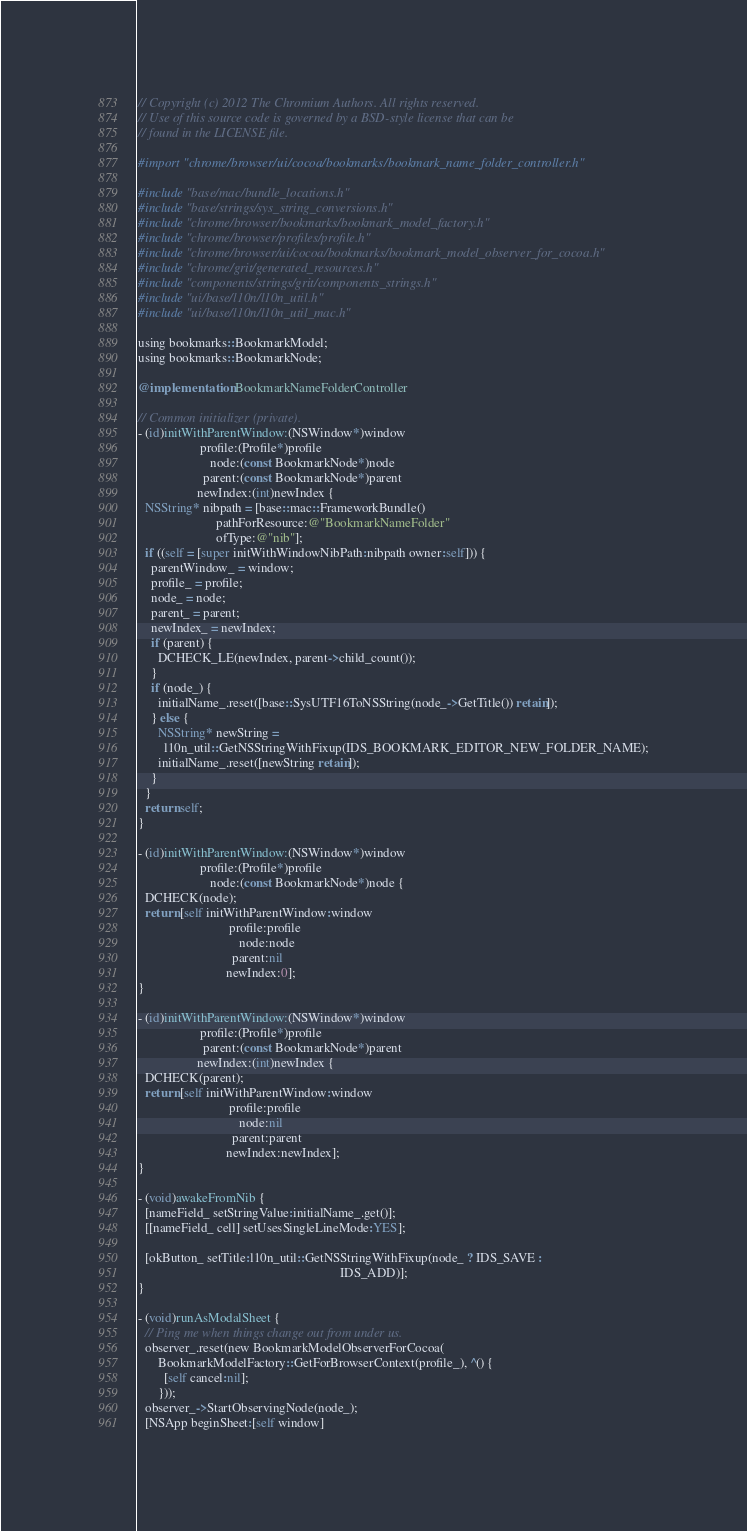Convert code to text. <code><loc_0><loc_0><loc_500><loc_500><_ObjectiveC_>// Copyright (c) 2012 The Chromium Authors. All rights reserved.
// Use of this source code is governed by a BSD-style license that can be
// found in the LICENSE file.

#import "chrome/browser/ui/cocoa/bookmarks/bookmark_name_folder_controller.h"

#include "base/mac/bundle_locations.h"
#include "base/strings/sys_string_conversions.h"
#include "chrome/browser/bookmarks/bookmark_model_factory.h"
#include "chrome/browser/profiles/profile.h"
#include "chrome/browser/ui/cocoa/bookmarks/bookmark_model_observer_for_cocoa.h"
#include "chrome/grit/generated_resources.h"
#include "components/strings/grit/components_strings.h"
#include "ui/base/l10n/l10n_util.h"
#include "ui/base/l10n/l10n_util_mac.h"

using bookmarks::BookmarkModel;
using bookmarks::BookmarkNode;

@implementation BookmarkNameFolderController

// Common initializer (private).
- (id)initWithParentWindow:(NSWindow*)window
                   profile:(Profile*)profile
                      node:(const BookmarkNode*)node
                    parent:(const BookmarkNode*)parent
                  newIndex:(int)newIndex {
  NSString* nibpath = [base::mac::FrameworkBundle()
                        pathForResource:@"BookmarkNameFolder"
                        ofType:@"nib"];
  if ((self = [super initWithWindowNibPath:nibpath owner:self])) {
    parentWindow_ = window;
    profile_ = profile;
    node_ = node;
    parent_ = parent;
    newIndex_ = newIndex;
    if (parent) {
      DCHECK_LE(newIndex, parent->child_count());
    }
    if (node_) {
      initialName_.reset([base::SysUTF16ToNSString(node_->GetTitle()) retain]);
    } else {
      NSString* newString =
        l10n_util::GetNSStringWithFixup(IDS_BOOKMARK_EDITOR_NEW_FOLDER_NAME);
      initialName_.reset([newString retain]);
    }
  }
  return self;
}

- (id)initWithParentWindow:(NSWindow*)window
                   profile:(Profile*)profile
                      node:(const BookmarkNode*)node {
  DCHECK(node);
  return [self initWithParentWindow:window
                            profile:profile
                               node:node
                             parent:nil
                           newIndex:0];
}

- (id)initWithParentWindow:(NSWindow*)window
                   profile:(Profile*)profile
                    parent:(const BookmarkNode*)parent
                  newIndex:(int)newIndex {
  DCHECK(parent);
  return [self initWithParentWindow:window
                            profile:profile
                               node:nil
                             parent:parent
                           newIndex:newIndex];
}

- (void)awakeFromNib {
  [nameField_ setStringValue:initialName_.get()];
  [[nameField_ cell] setUsesSingleLineMode:YES];

  [okButton_ setTitle:l10n_util::GetNSStringWithFixup(node_ ? IDS_SAVE :
                                                              IDS_ADD)];
}

- (void)runAsModalSheet {
  // Ping me when things change out from under us.
  observer_.reset(new BookmarkModelObserverForCocoa(
      BookmarkModelFactory::GetForBrowserContext(profile_), ^() {
        [self cancel:nil];
      }));
  observer_->StartObservingNode(node_);
  [NSApp beginSheet:[self window]</code> 